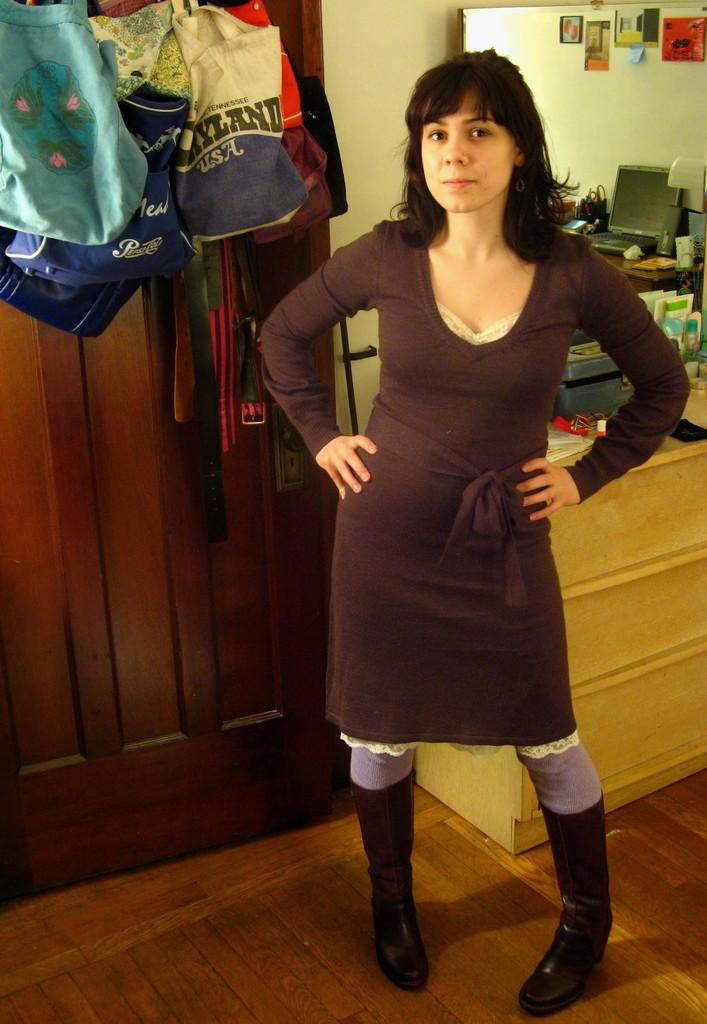<image>
Create a compact narrative representing the image presented. A woman standing in a house in front of some shopping bags, one of which is a Pepsi Cola bag 